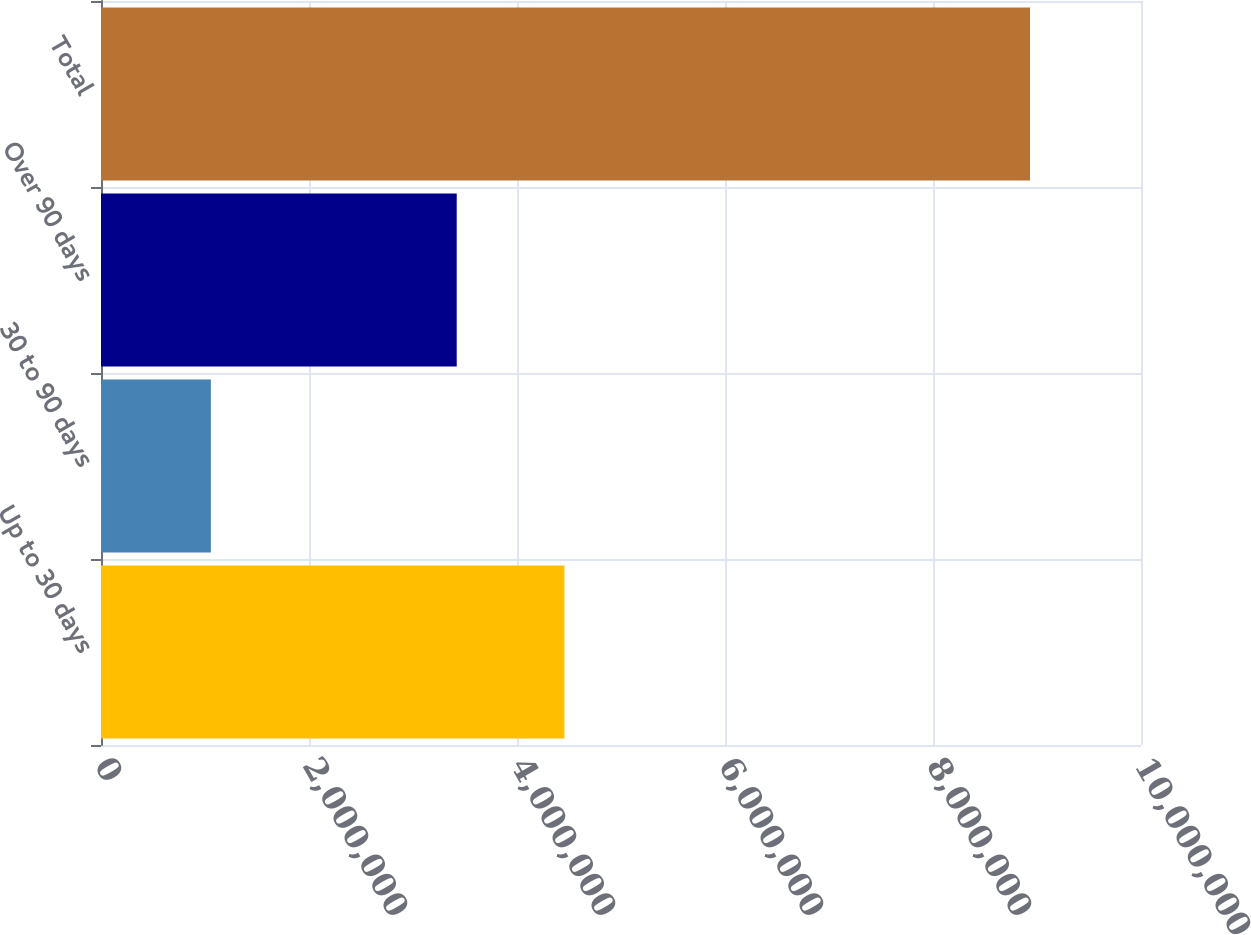<chart> <loc_0><loc_0><loc_500><loc_500><bar_chart><fcel>Up to 30 days<fcel>30 to 90 days<fcel>Over 90 days<fcel>Total<nl><fcel>4.45592e+06<fcel>1.05639e+06<fcel>3.42039e+06<fcel>8.93269e+06<nl></chart> 